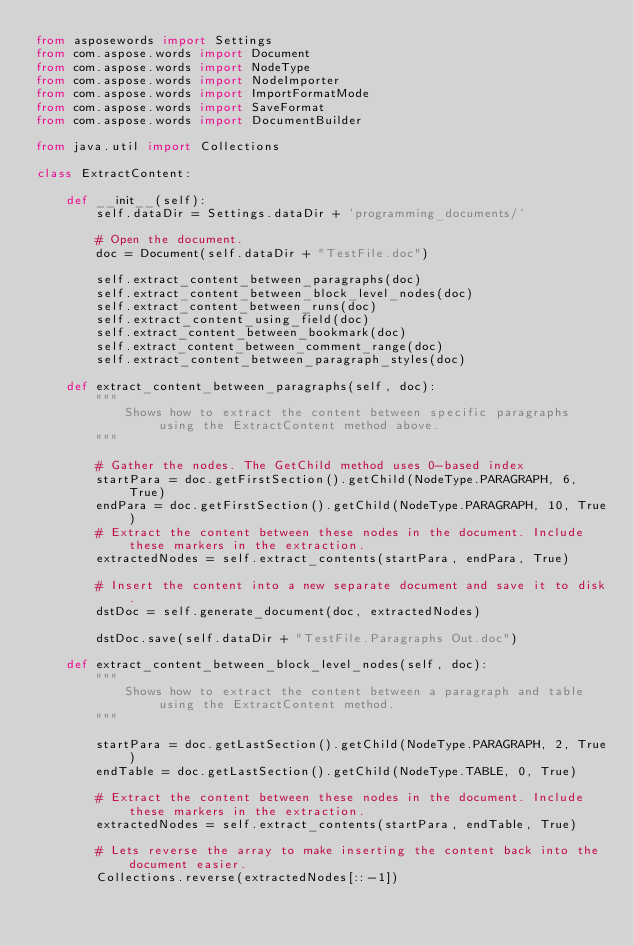<code> <loc_0><loc_0><loc_500><loc_500><_Python_>from asposewords import Settings
from com.aspose.words import Document
from com.aspose.words import NodeType
from com.aspose.words import NodeImporter
from com.aspose.words import ImportFormatMode
from com.aspose.words import SaveFormat
from com.aspose.words import DocumentBuilder

from java.util import Collections

class ExtractContent:

    def __init__(self):
        self.dataDir = Settings.dataDir + 'programming_documents/'
        
        # Open the document.
        doc = Document(self.dataDir + "TestFile.doc")
        
        self.extract_content_between_paragraphs(doc)
        self.extract_content_between_block_level_nodes(doc)
        self.extract_content_between_runs(doc)
        self.extract_content_using_field(doc)
        self.extract_content_between_bookmark(doc)
        self.extract_content_between_comment_range(doc)
        self.extract_content_between_paragraph_styles(doc)
    
    def extract_content_between_paragraphs(self, doc):
        """
            Shows how to extract the content between specific paragraphs using the ExtractContent method above.
        """
        
        # Gather the nodes. The GetChild method uses 0-based index
        startPara = doc.getFirstSection().getChild(NodeType.PARAGRAPH, 6, True)
        endPara = doc.getFirstSection().getChild(NodeType.PARAGRAPH, 10, True)
        # Extract the content between these nodes in the document. Include these markers in the extraction.
        extractedNodes = self.extract_contents(startPara, endPara, True)

        # Insert the content into a new separate document and save it to disk.
        dstDoc = self.generate_document(doc, extractedNodes)
        
        dstDoc.save(self.dataDir + "TestFile.Paragraphs Out.doc")
        
    def extract_content_between_block_level_nodes(self, doc):
        """
            Shows how to extract the content between a paragraph and table using the ExtractContent method.
        """

        startPara = doc.getLastSection().getChild(NodeType.PARAGRAPH, 2, True)
        endTable = doc.getLastSection().getChild(NodeType.TABLE, 0, True)

        # Extract the content between these nodes in the document. Include these markers in the extraction.
        extractedNodes = self.extract_contents(startPara, endTable, True)

        # Lets reverse the array to make inserting the content back into the document easier.
        Collections.reverse(extractedNodes[::-1])
</code> 